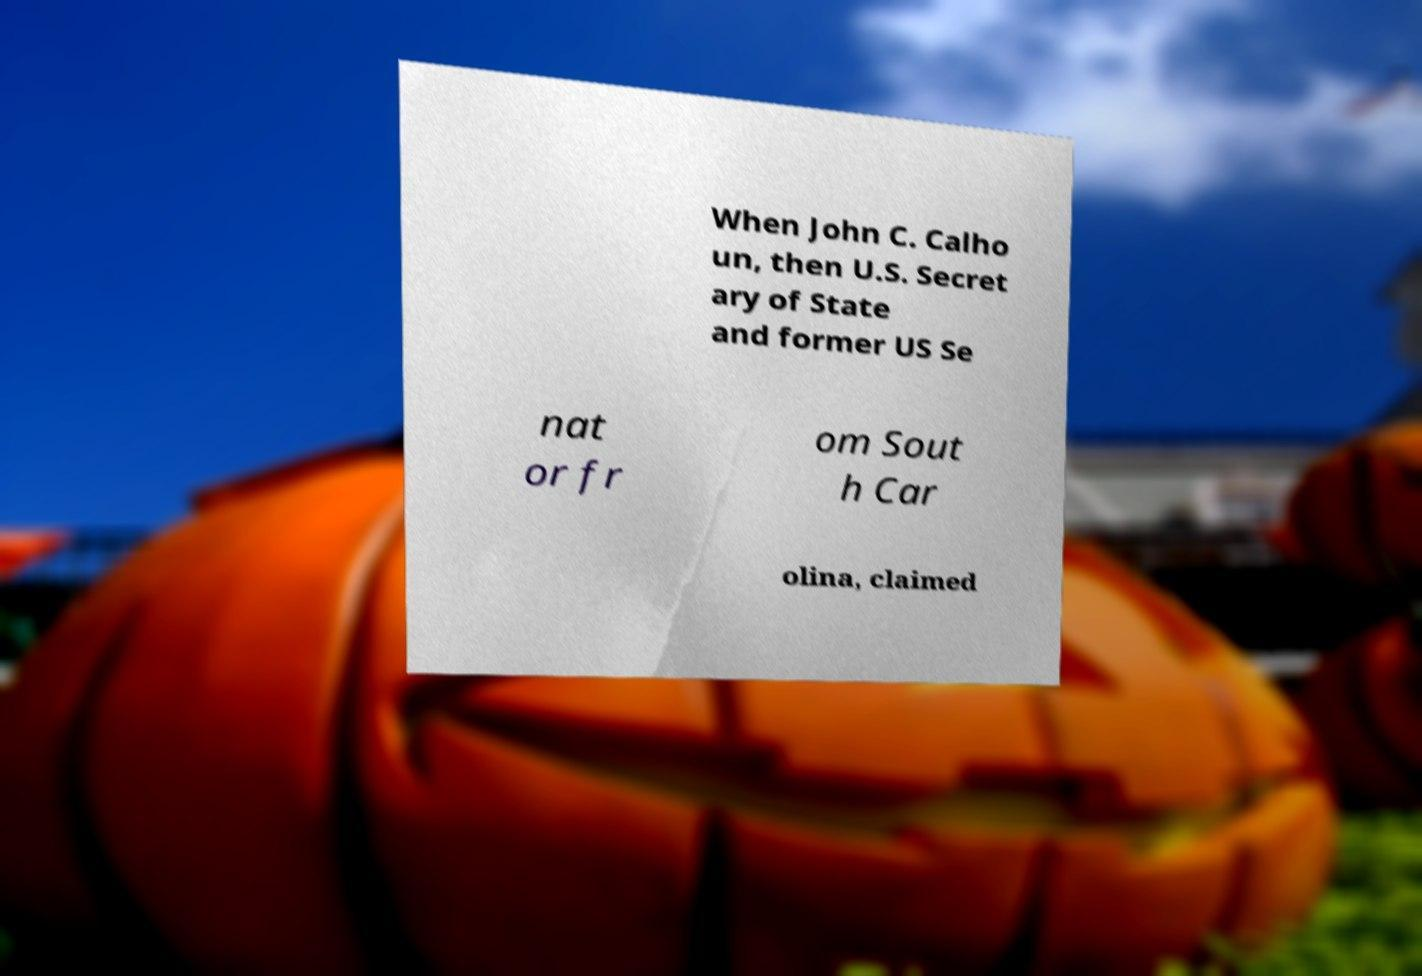Could you extract and type out the text from this image? When John C. Calho un, then U.S. Secret ary of State and former US Se nat or fr om Sout h Car olina, claimed 